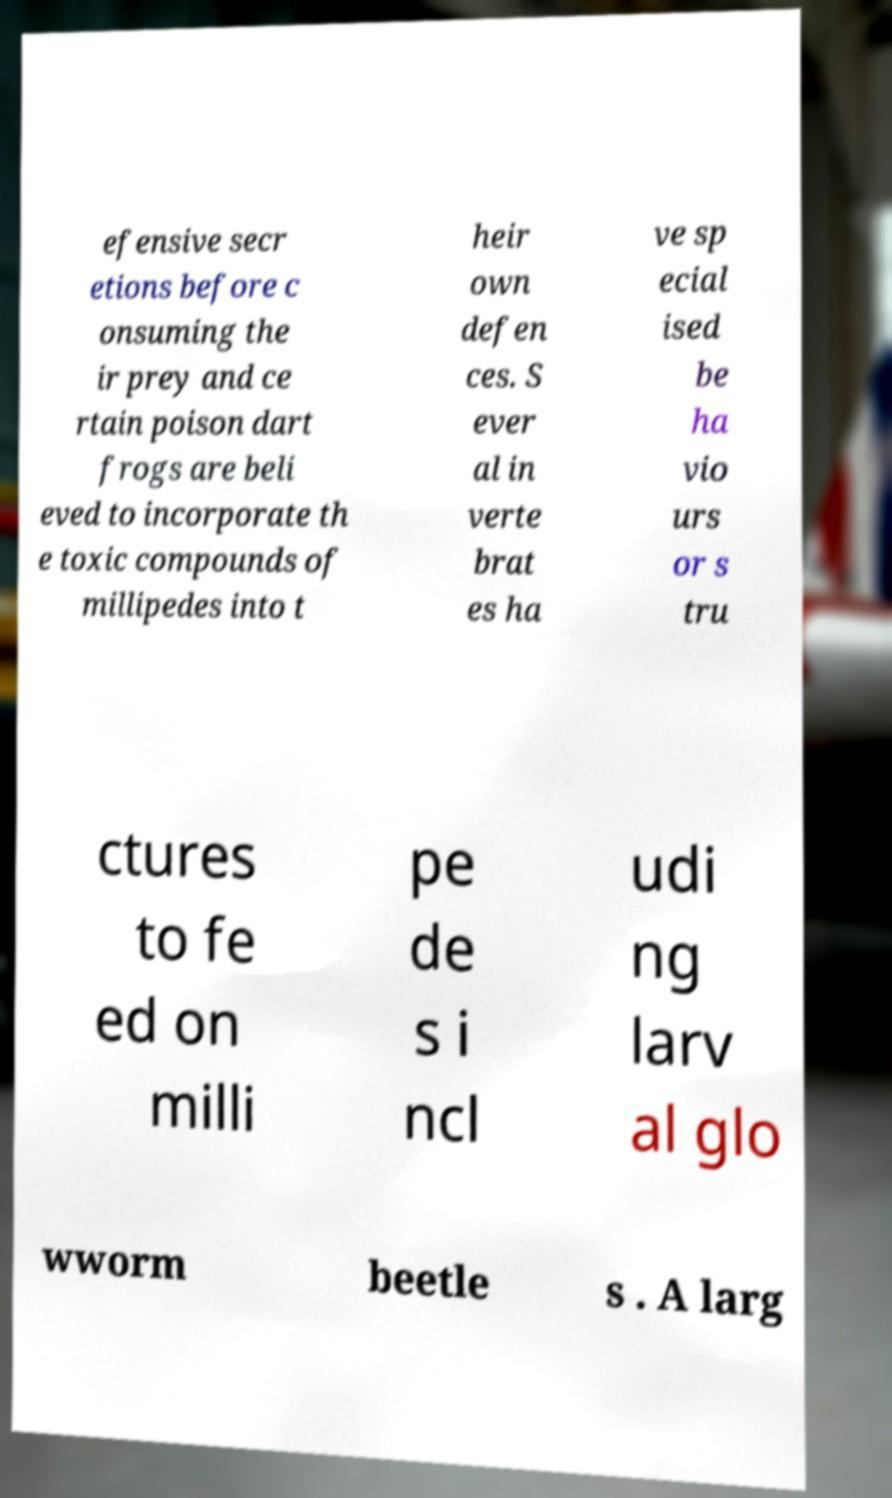Can you read and provide the text displayed in the image?This photo seems to have some interesting text. Can you extract and type it out for me? efensive secr etions before c onsuming the ir prey and ce rtain poison dart frogs are beli eved to incorporate th e toxic compounds of millipedes into t heir own defen ces. S ever al in verte brat es ha ve sp ecial ised be ha vio urs or s tru ctures to fe ed on milli pe de s i ncl udi ng larv al glo wworm beetle s . A larg 